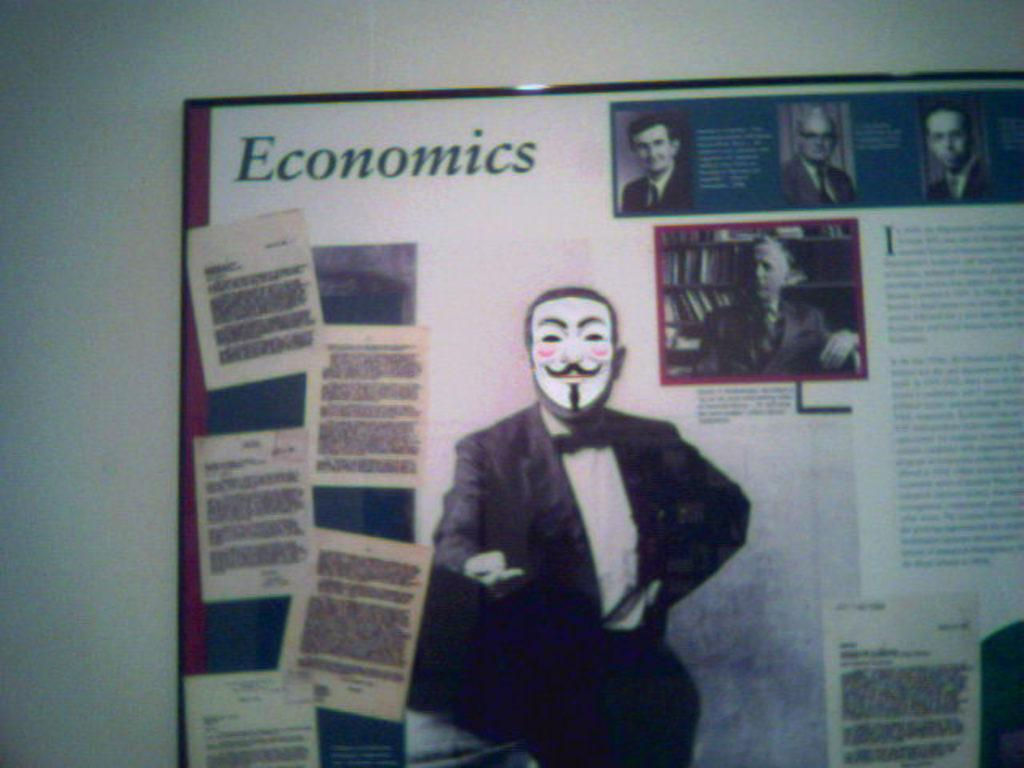What is attached to the wall in the image? There is a board on a wall in the image. What is displayed on the board? There are notices and images of persons on the board. Is there any text on the board? Yes, something is written on the board. What type of beef is being advertised on the board in the image? There is no mention of beef or any food item in the image; the board contains notices and images of persons. 